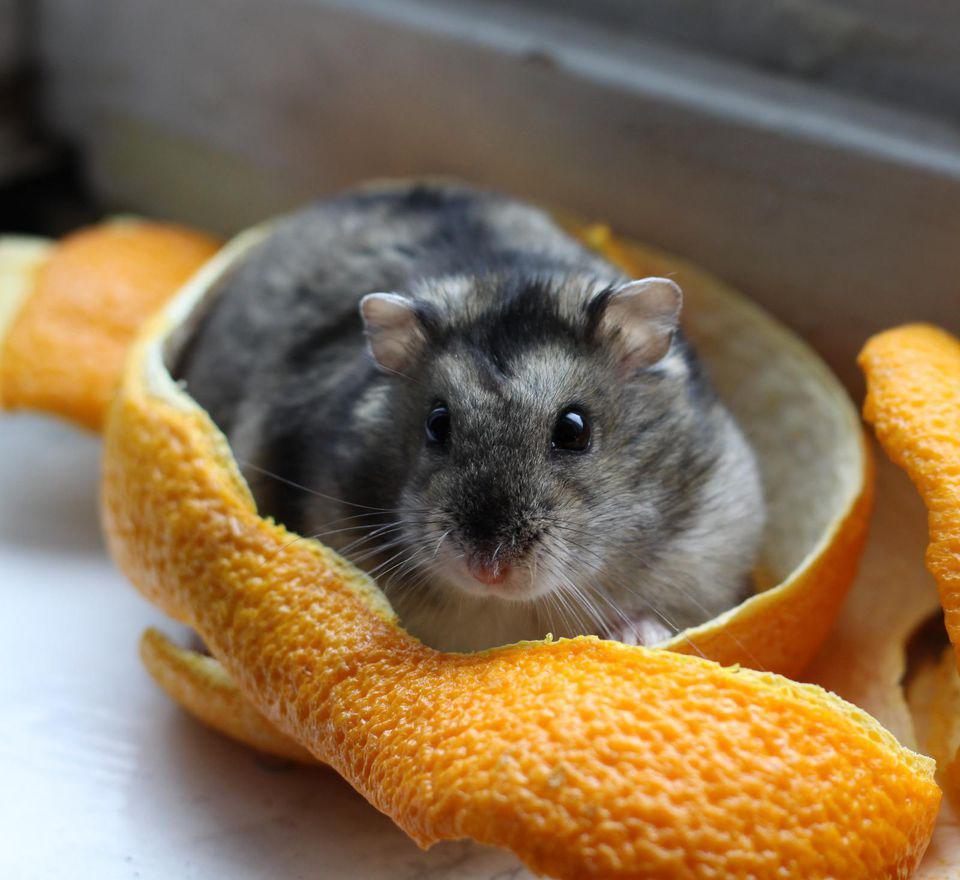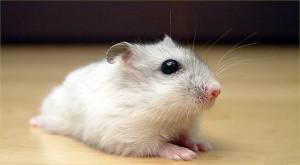The first image is the image on the left, the second image is the image on the right. Evaluate the accuracy of this statement regarding the images: "One image shows a hand holding more than one small rodent.". Is it true? Answer yes or no. No. The first image is the image on the left, the second image is the image on the right. For the images displayed, is the sentence "A human hand is holding some hamsters." factually correct? Answer yes or no. No. 